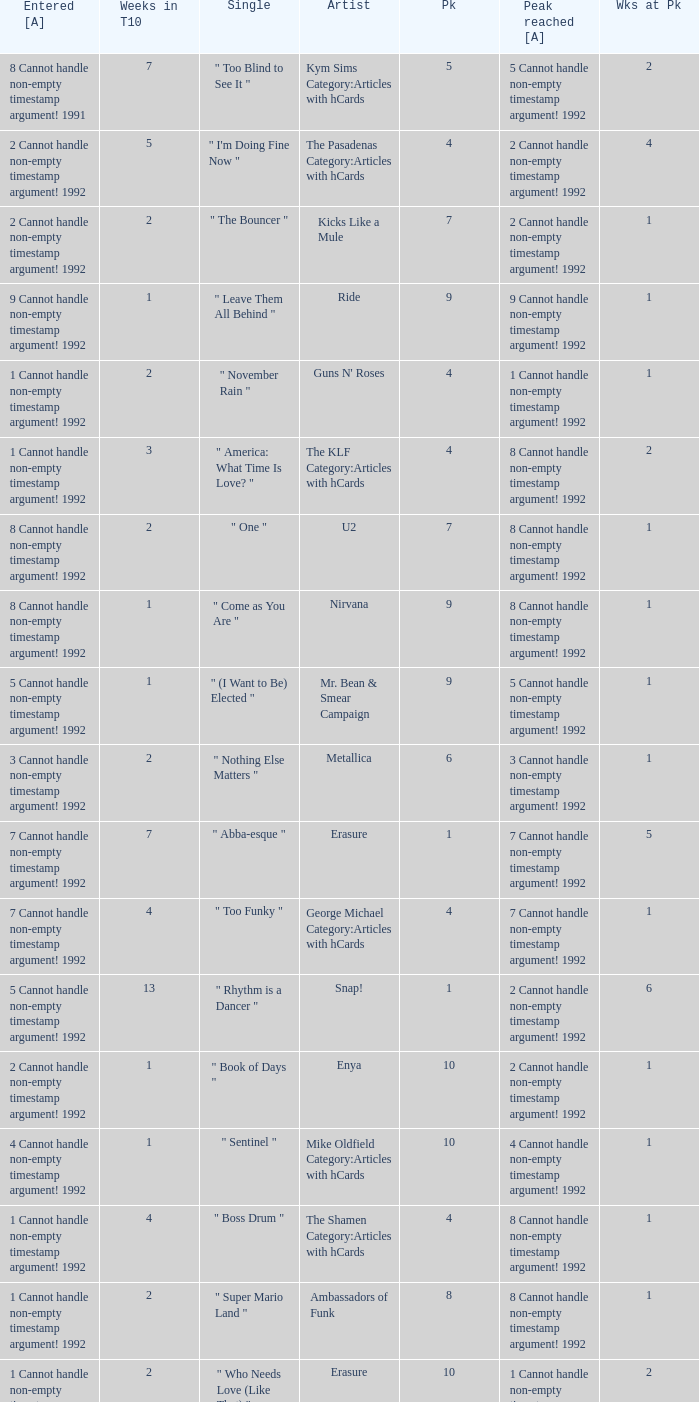If the peak reached is 6 cannot handle non-empty timestamp argument! 1992, what is the entered? 6 Cannot handle non-empty timestamp argument! 1992. 